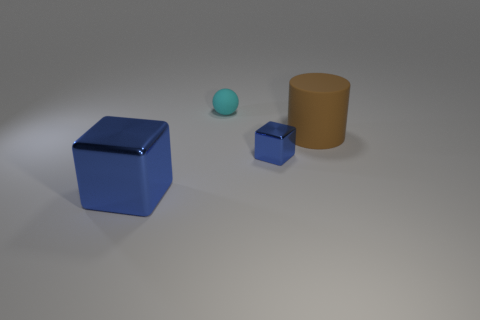Add 2 big gray metal spheres. How many objects exist? 6 Subtract all balls. How many objects are left? 3 Subtract all big purple rubber spheres. Subtract all matte cylinders. How many objects are left? 3 Add 3 small blue metal things. How many small blue metal things are left? 4 Add 4 yellow shiny cylinders. How many yellow shiny cylinders exist? 4 Subtract 0 cyan cubes. How many objects are left? 4 